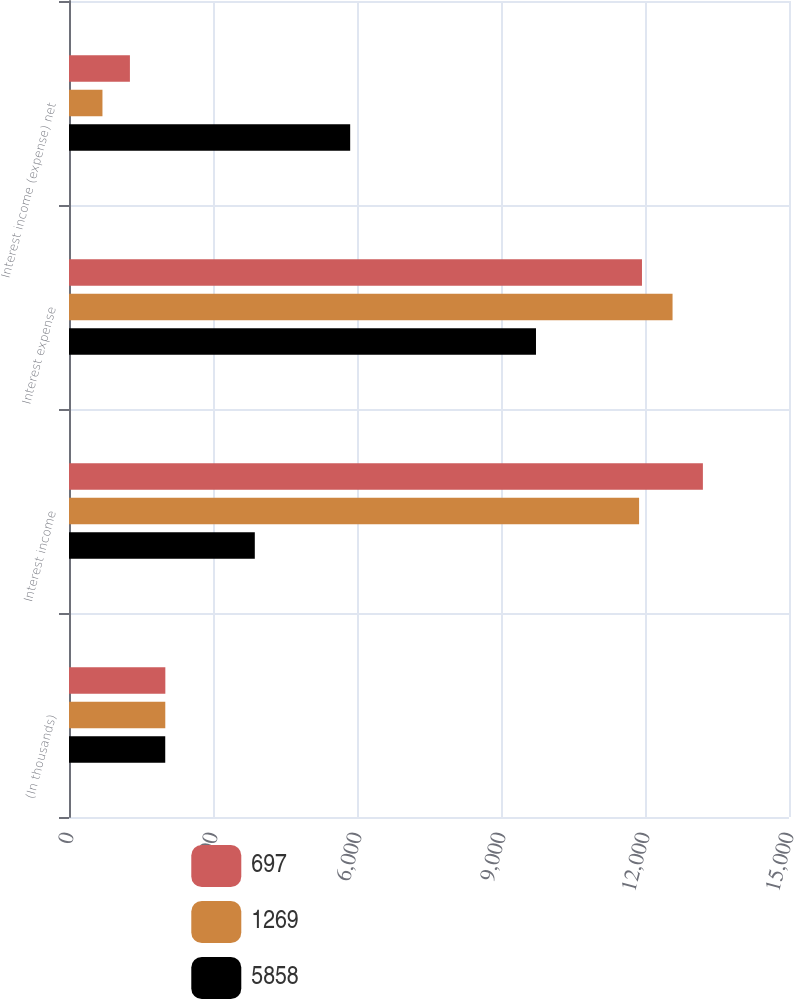Convert chart to OTSL. <chart><loc_0><loc_0><loc_500><loc_500><stacked_bar_chart><ecel><fcel>(In thousands)<fcel>Interest income<fcel>Interest expense<fcel>Interest income (expense) net<nl><fcel>697<fcel>2007<fcel>13206<fcel>11937<fcel>1269<nl><fcel>1269<fcel>2006<fcel>11877<fcel>12574<fcel>697<nl><fcel>5858<fcel>2005<fcel>3871<fcel>9729<fcel>5858<nl></chart> 